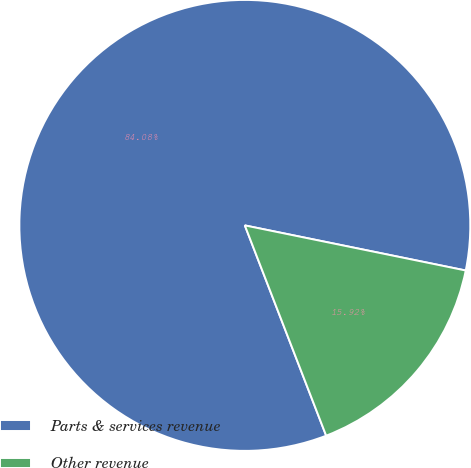Convert chart to OTSL. <chart><loc_0><loc_0><loc_500><loc_500><pie_chart><fcel>Parts & services revenue<fcel>Other revenue<nl><fcel>84.08%<fcel>15.92%<nl></chart> 